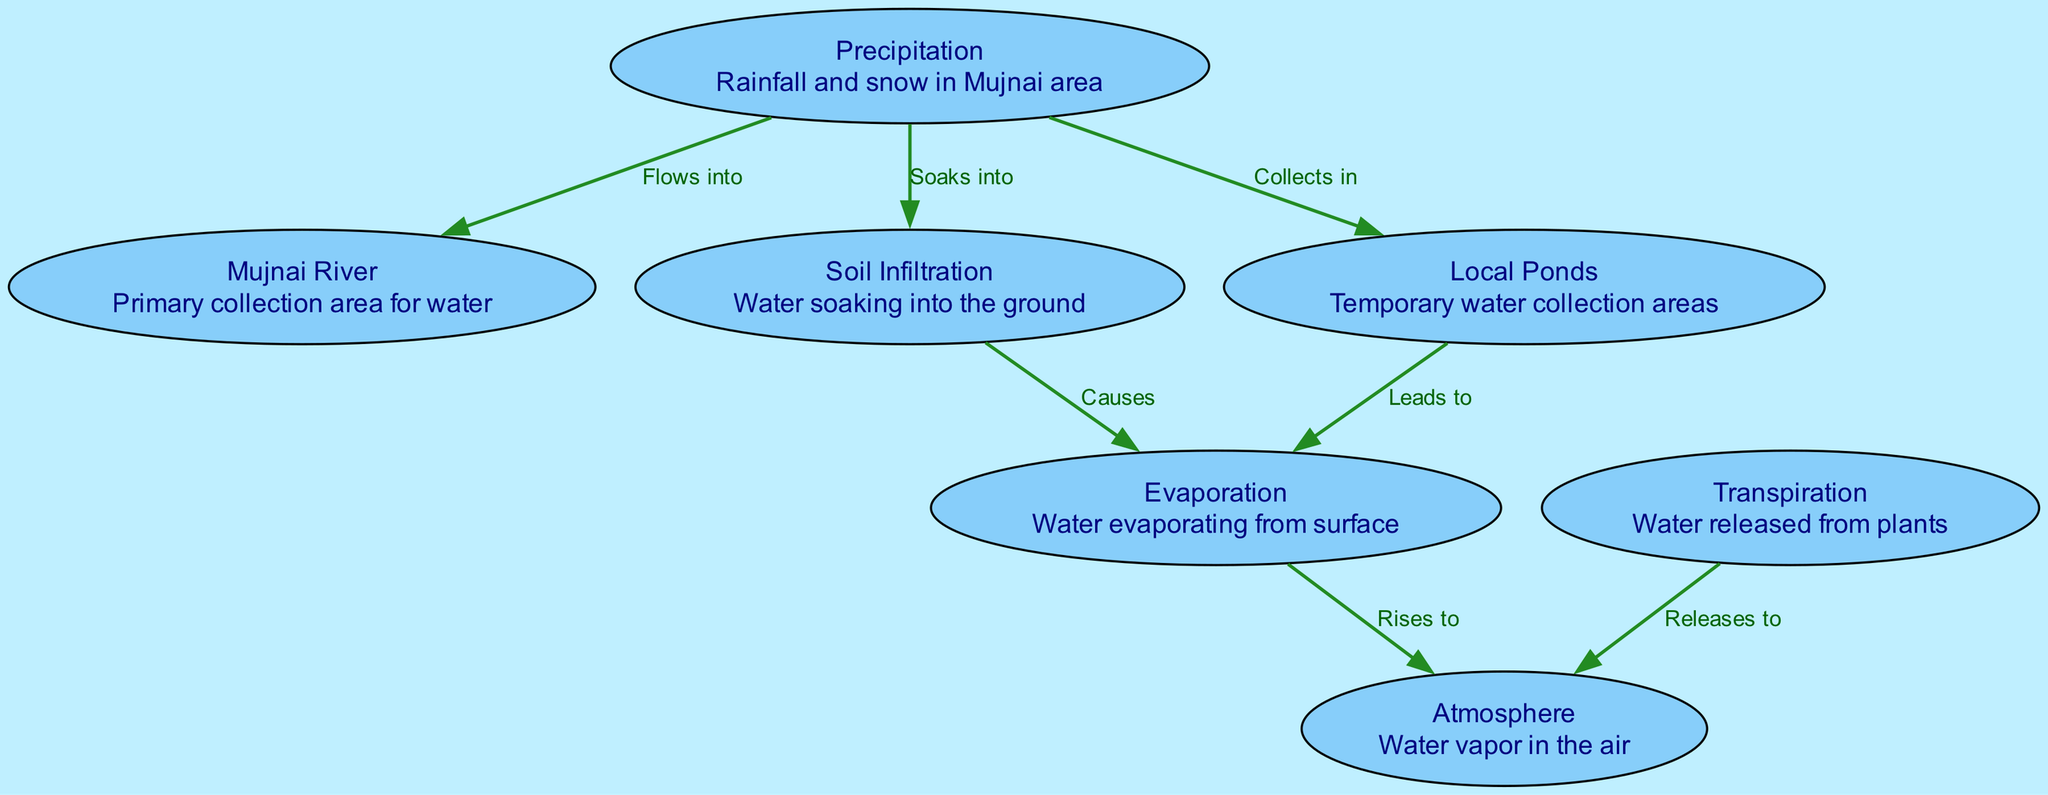What are the two types of precipitation noted in the diagram? The diagram mentions "Rainfall" and "Snow" under the "Precipitation" node, as these are the two forms of precipitation observed in the Mujnai area.
Answer: Rainfall and Snow Which node represents the primary collection area for water? The "Mujnai River" is described in the diagram as the primary collection area for water. This is indicated directly in the node labeled "Mujnai River."
Answer: Mujnai River How many nodes are present in this water cycle diagram? The diagram contains a total of 7 distinct nodes, as listed individually in the "nodes" section of the data.
Answer: 7 What leads to evaporation from local ponds? The arrow from the "Local Ponds" node to the "Evaporation" node indicates that water collected in local ponds "Leads to" evaporation, as per the labeled edge relationship in the diagram.
Answer: Leads to What is the significance of transpiration in the water cycle illustrated? The "Transpiration" node represents the process of water being released from plants. This water vapor then "Releases to" the atmosphere, indicating its role in transferring moisture.
Answer: Releases to Which element causes both evaporation from soil infiltration and local ponds? The "Soil Infiltration" node causes evaporation ("Causes" relationship) from soil as well as the "Local Ponds" which also leads to evaporation, as established by the edges connecting these nodes to the "Evaporation" node.
Answer: Evaporation How does water vapor return to the atmosphere according to the diagram? Water vapor returns to the atmosphere through two processes: first, "Evaporation" from surfaces ("Rises to" relationship), and second, "Transpiration" from plants, both of which are illustrated with directed edges leading towards the "Atmosphere" node.
Answer: Rises to and Releases to What connects precipitation to soil infiltration in the diagram? The connection from "Precipitation" to "Soil Infiltration" is established through the labeled relationship "Soaks into," indicating how water from precipitation is absorbed by the soil.
Answer: Soaks into 